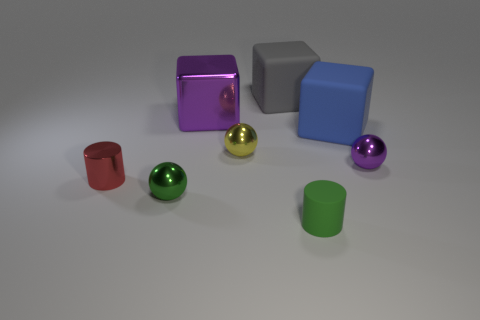Do the matte object in front of the tiny purple thing and the shiny cube have the same color?
Your response must be concise. No. What number of balls are small cyan objects or big purple metal things?
Give a very brief answer. 0. There is a purple thing to the left of the cylinder that is in front of the ball that is in front of the red cylinder; what is its size?
Your response must be concise. Large. What shape is the blue object that is the same size as the gray cube?
Keep it short and to the point. Cube. What is the shape of the gray matte object?
Provide a short and direct response. Cube. Is the purple object to the left of the gray matte object made of the same material as the tiny red object?
Ensure brevity in your answer.  Yes. There is a red metallic cylinder that is left of the big rubber cube that is behind the blue rubber cube; what size is it?
Offer a very short reply. Small. What is the color of the rubber object that is behind the tiny shiny cylinder and in front of the large metallic thing?
Ensure brevity in your answer.  Blue. What material is the blue block that is the same size as the gray matte thing?
Your answer should be very brief. Rubber. How many other objects are there of the same material as the green cylinder?
Your response must be concise. 2. 